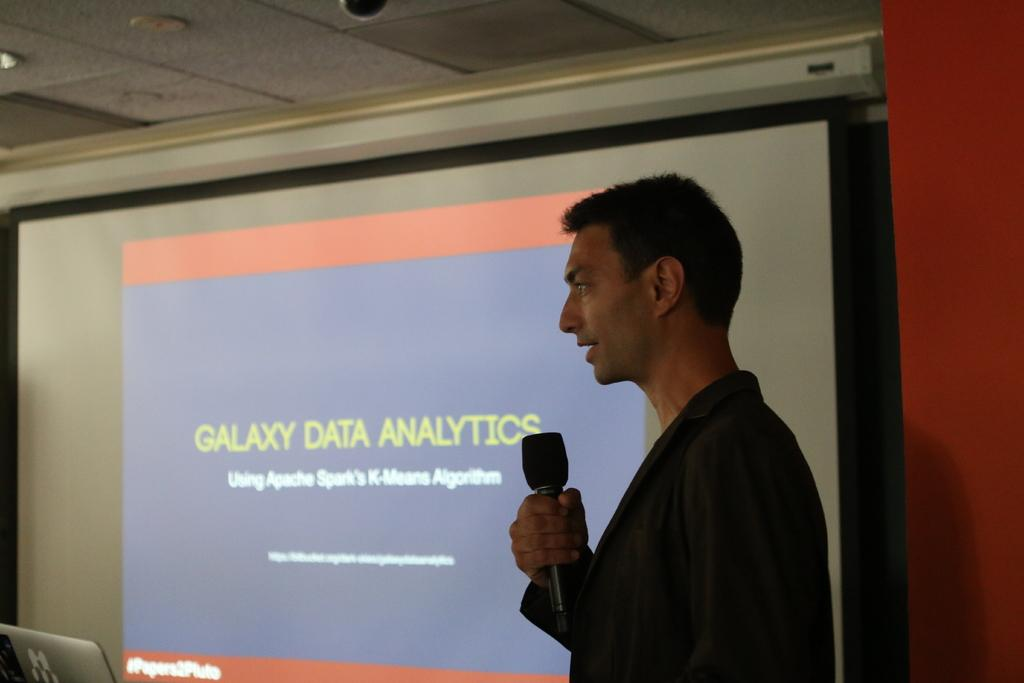What is the main object in the image? There is a screen in the image. What else can be seen in the background? There is a wall in the image. What device is present on the screen? There is a laptop in the image. Who is in the image? There is a person wearing a black color dress in the image. What is the person holding? The person is holding a mic. What type of tub is visible in the image? There is no tub present in the image. What shape is the circle that the person is drawing on the screen? There is no circle being drawn on the screen in the image. 